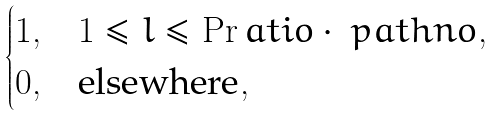<formula> <loc_0><loc_0><loc_500><loc_500>\begin{cases} 1 , & 1 \leq l \leq \Pr a t i o \cdot \ p a t h n o , \\ 0 , & \text {elsewhere} , \end{cases}</formula> 